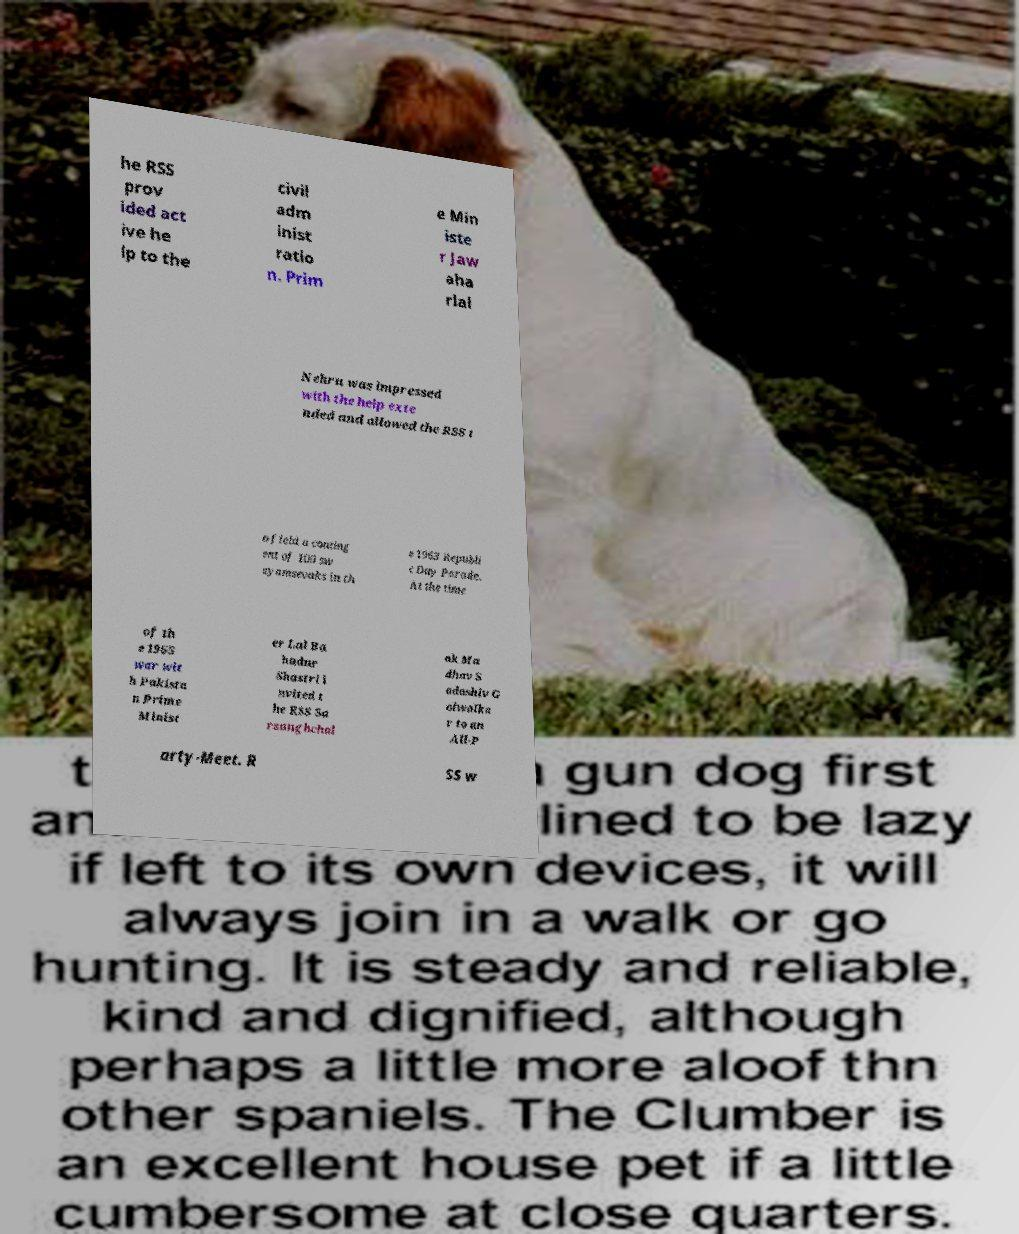What messages or text are displayed in this image? I need them in a readable, typed format. he RSS prov ided act ive he lp to the civil adm inist ratio n. Prim e Min iste r Jaw aha rlal Nehru was impressed with the help exte nded and allowed the RSS t o field a conting ent of 100 sw ayamsevaks in th e 1963 Republi c Day Parade. At the time of th e 1965 war wit h Pakista n Prime Minist er Lal Ba hadur Shastri i nvited t he RSS Sa rsanghchal ak Ma dhav S adashiv G olwalka r to an All-P arty-Meet. R SS w 